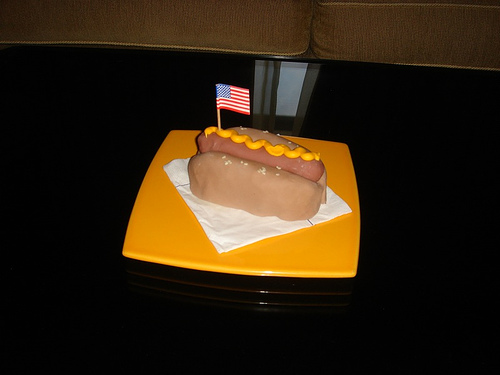Is this hotdog being served at a special event? Given the small American flag stuck into it, the hotdog may indeed be part of a celebration or themed event, likely related to an American holiday or patriotic occasion. 